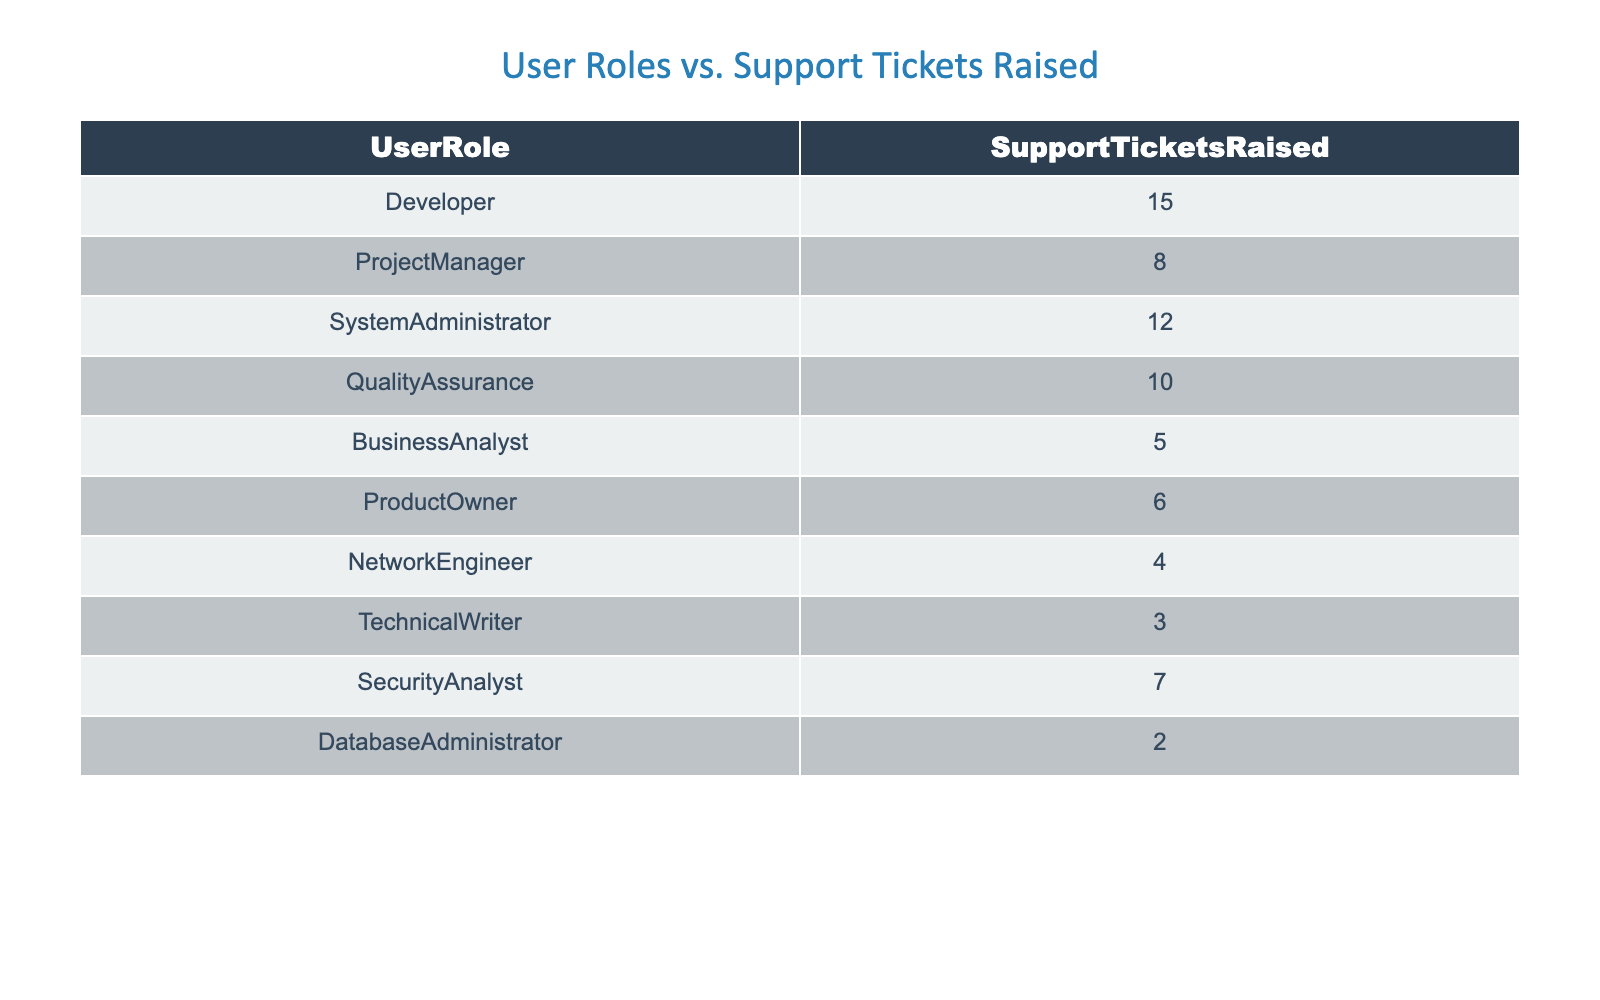What is the total number of support tickets raised by all user roles? To find the total, we need to add up all the support tickets raised by each user role: 15 (Developer) + 8 (ProjectManager) + 12 (SystemAdministrator) + 10 (QualityAssurance) + 5 (BusinessAnalyst) + 6 (ProductOwner) + 4 (NetworkEngineer) + 3 (TechnicalWriter) + 7 (SecurityAnalyst) + 2 (DatabaseAdministrator) = 72.
Answer: 72 Which user role raised the least number of support tickets? By reviewing the table, we see that the DatabaseAdministrator has raised the fewest support tickets, totaling 2.
Answer: DatabaseAdministrator What is the difference in the number of support tickets raised between the Developer and the Quality Assurance roles? The Developer raised 15 support tickets, while Quality Assurance raised 10. The difference is calculated as 15 - 10 = 5.
Answer: 5 Is it true that the System Administrator raised more support tickets than the Business Analyst? The System Administrator raised a total of 12 support tickets and the Business Analyst raised 5. Since 12 is greater than 5, the statement is true.
Answer: Yes What is the average number of support tickets raised across all user roles? First, we add up the total number of support tickets, which is 72 as calculated before. Since there are 10 user roles, we divide the total by 10: 72 / 10 = 7.2.
Answer: 7.2 Which user role raised more support tickets, the Technical Writer or the Network Engineer? The Technical Writer raised 3 tickets and the Network Engineer raised 4 tickets. Comparing the two, 4 is greater than 3, meaning the Network Engineer raised more tickets.
Answer: Network Engineer How many user roles raised more than 6 support tickets? We need to tally the user roles that have raised more than 6 tickets. The roles that fit this criterion are Developer (15), ProjectManager (8), SystemAdministrator (12), QualityAssurance (10), SecurityAnalyst (7), and ProductOwner (6). This makes a total of 5 user roles.
Answer: 5 What is the total number of support tickets raised by the top three user roles? The top three user roles by ticket count are Developer (15), SystemAdministrator (12), and QualityAssurance (10). To find the total, we add them together: 15 + 12 + 10 = 37.
Answer: 37 Is there any user role that raised exactly 6 support tickets? By checking the table, we can see that the ProductOwner raised exactly 6 support tickets, so this statement is true.
Answer: Yes 